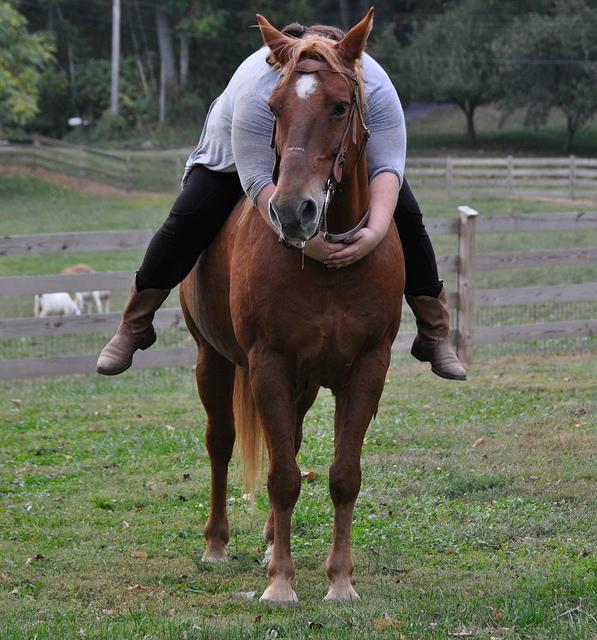Why is the woman touching the horse?
Short answer required. Hug. Does this person have a head?
Quick response, please. Yes. What is the girl training for?
Short answer required. Horse riding. Could the woman be the horse's owner?
Write a very short answer. Yes. In this picture can you see all four of the horse's hooves?
Answer briefly. Yes. Is there a saddle?
Answer briefly. No. What kind of ground are they riding on?
Answer briefly. Grass. Is this woman enjoying herself?
Give a very brief answer. Yes. Is she comfortable around horses?
Answer briefly. Yes. What color is the horse?
Be succinct. Brown. Is the horse wearing a saddle?
Give a very brief answer. No. What does the horse have on his head?
Short answer required. Nothing. 